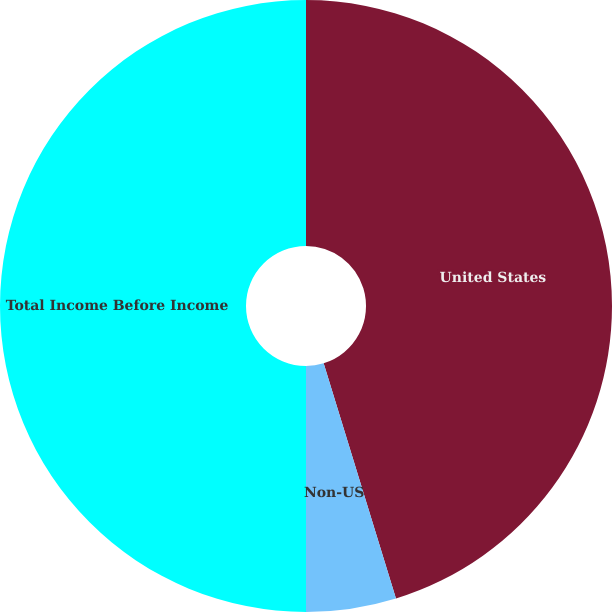Convert chart to OTSL. <chart><loc_0><loc_0><loc_500><loc_500><pie_chart><fcel>United States<fcel>Non-US<fcel>Total Income Before Income<nl><fcel>45.25%<fcel>4.75%<fcel>50.0%<nl></chart> 